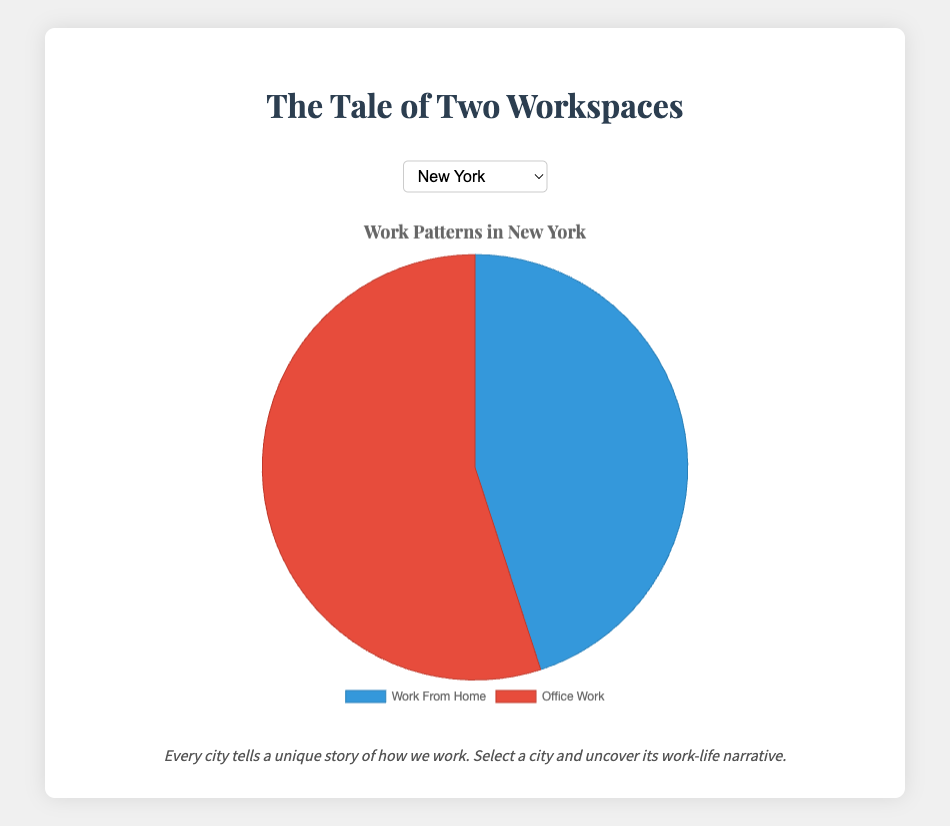What's the source of the data used in this chart? The data derived from the chart code shows work-from-home and office work percentages for major cities.
Answer: Work-from-home vs. Office work Which city has the highest percentage of work-from-home? Comparing all cities in the chart, San Francisco has the highest percentage (60%) of work-from-home.
Answer: San Francisco Which city has equal percentages of work-from-home and office work? London's chart indicates a 50-50 split between work-from-home and office work.
Answer: London Between New York and Tokyo, which city has a higher percentage of work-from-home? New York's work-from-home percentage is 45% while Tokyo's is 35%.
Answer: New York What is the difference in office work percentages between New York and San Francisco? New York has 55% office work and San Francisco has 40%. The difference is 55 - 40 = 15%.
Answer: 15% How many cities have more than 50% of workers working from home? San Francisco (60%) and Berlin (55%) both have work-from-home percentages higher than 50%.
Answer: 2 Which city has the lowest percentage of work-from-home? Tokyo shows the lowest work-from-home percentage at 35%.
Answer: Tokyo If you combine the percentages of work-from-home in San Francisco and Berlin, what is the total? Adding San Francisco's 60% and Berlin's 55% equals 115%.
Answer: 115% Compare the visual color of the office work portion for New York and Tokyo. What color does both share? Both New York and Tokyo's office work portions are colored in red on the chart.
Answer: Red Is the work-from-home percentage in Sydney closer to New York's or London's percentage? Sydney's work-from-home percentage is 48%, closer to New York's 45% than London's 50%.
Answer: New York 